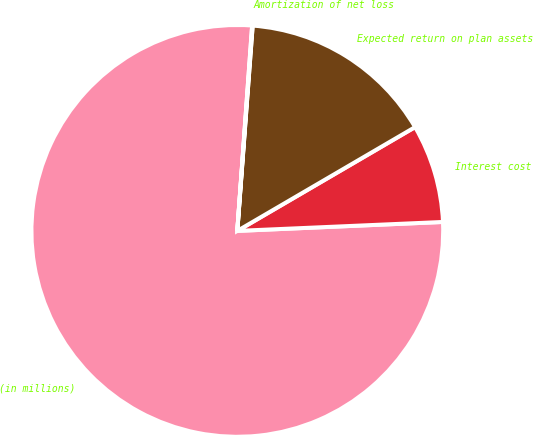Convert chart to OTSL. <chart><loc_0><loc_0><loc_500><loc_500><pie_chart><fcel>(in millions)<fcel>Interest cost<fcel>Expected return on plan assets<fcel>Amortization of net loss<nl><fcel>76.84%<fcel>7.72%<fcel>15.4%<fcel>0.04%<nl></chart> 